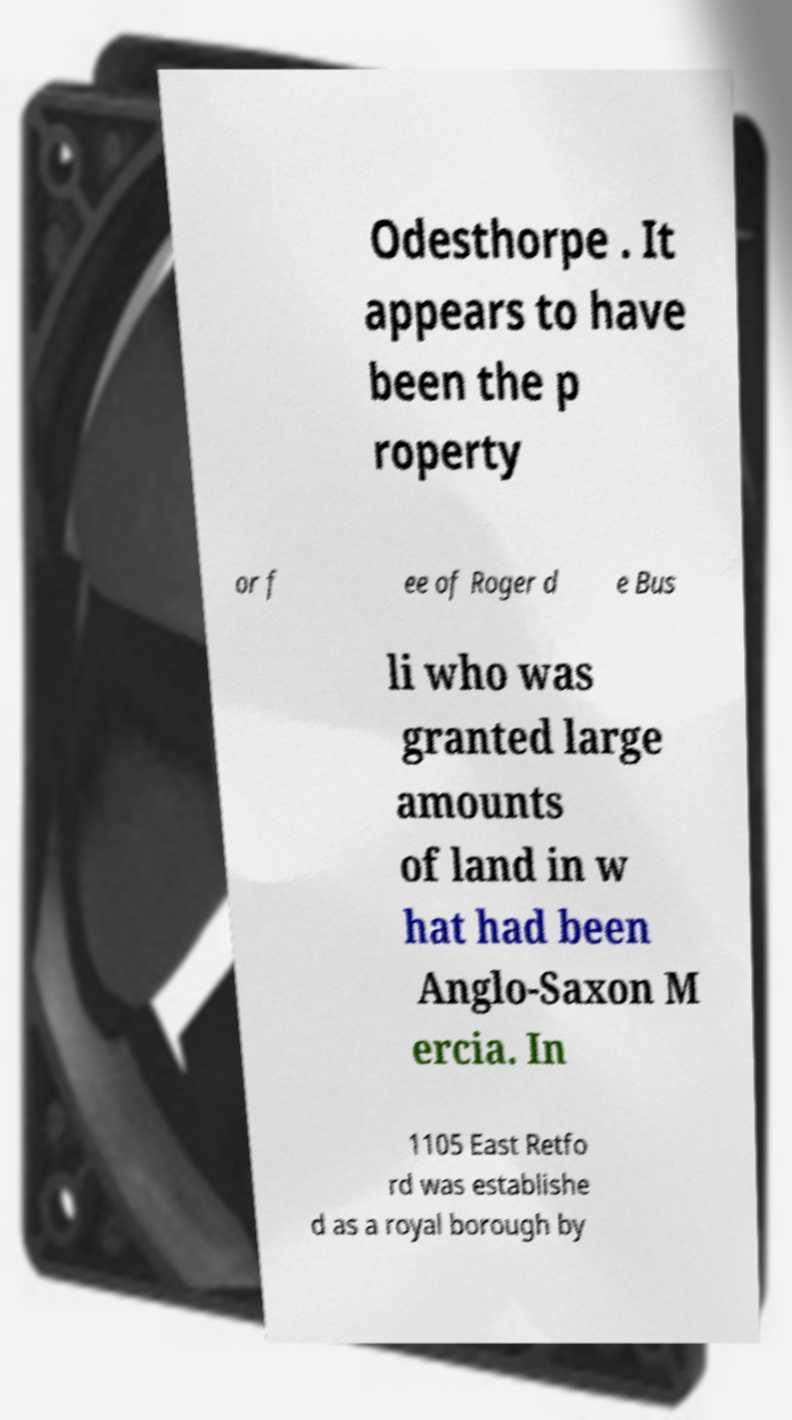Can you read and provide the text displayed in the image?This photo seems to have some interesting text. Can you extract and type it out for me? Odesthorpe . It appears to have been the p roperty or f ee of Roger d e Bus li who was granted large amounts of land in w hat had been Anglo-Saxon M ercia. In 1105 East Retfo rd was establishe d as a royal borough by 